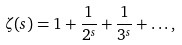<formula> <loc_0><loc_0><loc_500><loc_500>\zeta ( s ) = 1 + \frac { 1 } { 2 ^ { s } } + \frac { 1 } { 3 ^ { s } } + \dots ,</formula> 